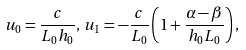<formula> <loc_0><loc_0><loc_500><loc_500>u _ { 0 } = \frac { c } { L _ { 0 } h _ { 0 } } , \, u _ { 1 } = - \frac { c } { L _ { 0 } } \left ( 1 + \frac { \alpha - \beta } { h _ { 0 } L _ { 0 } } \right ) ,</formula> 